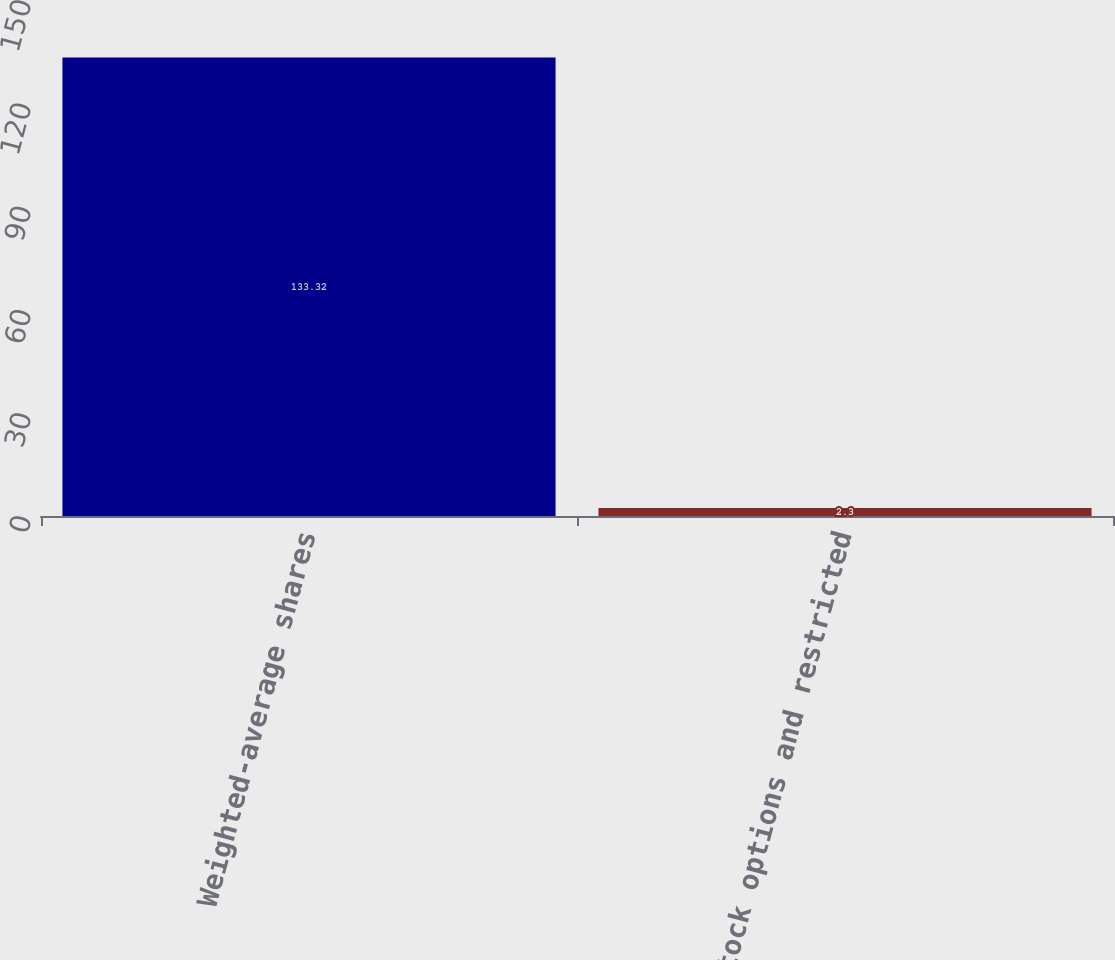<chart> <loc_0><loc_0><loc_500><loc_500><bar_chart><fcel>Weighted-average shares<fcel>Stock options and restricted<nl><fcel>133.32<fcel>2.3<nl></chart> 